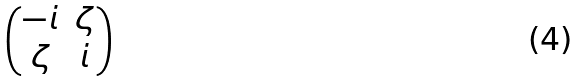<formula> <loc_0><loc_0><loc_500><loc_500>\begin{pmatrix} - i & \zeta \\ \zeta & i \end{pmatrix}</formula> 